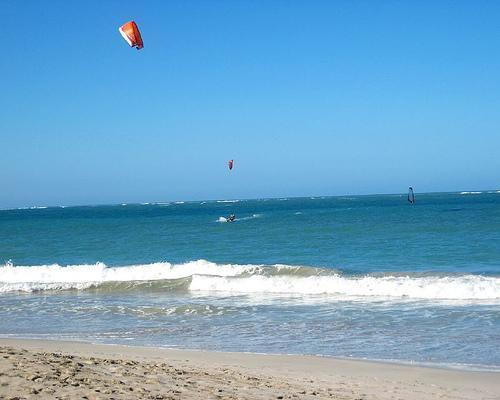How many para-sailers are in the water?
Give a very brief answer. 1. How many people can be seen?
Give a very brief answer. 1. How many kites are flying?
Give a very brief answer. 2. How many statues on the clock have wings?
Give a very brief answer. 0. 